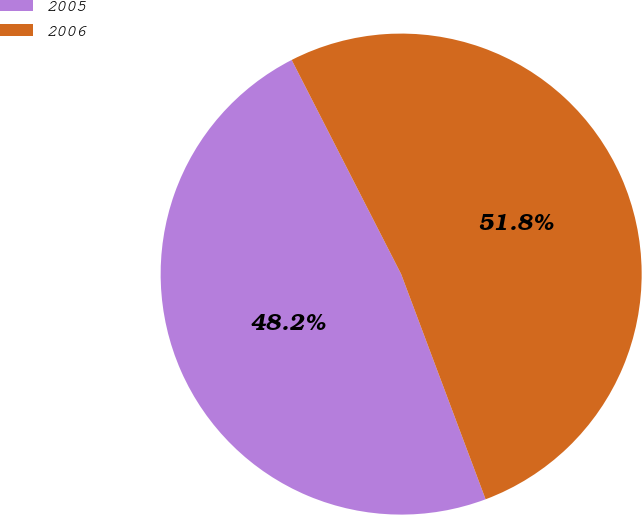Convert chart. <chart><loc_0><loc_0><loc_500><loc_500><pie_chart><fcel>2005<fcel>2006<nl><fcel>48.19%<fcel>51.81%<nl></chart> 